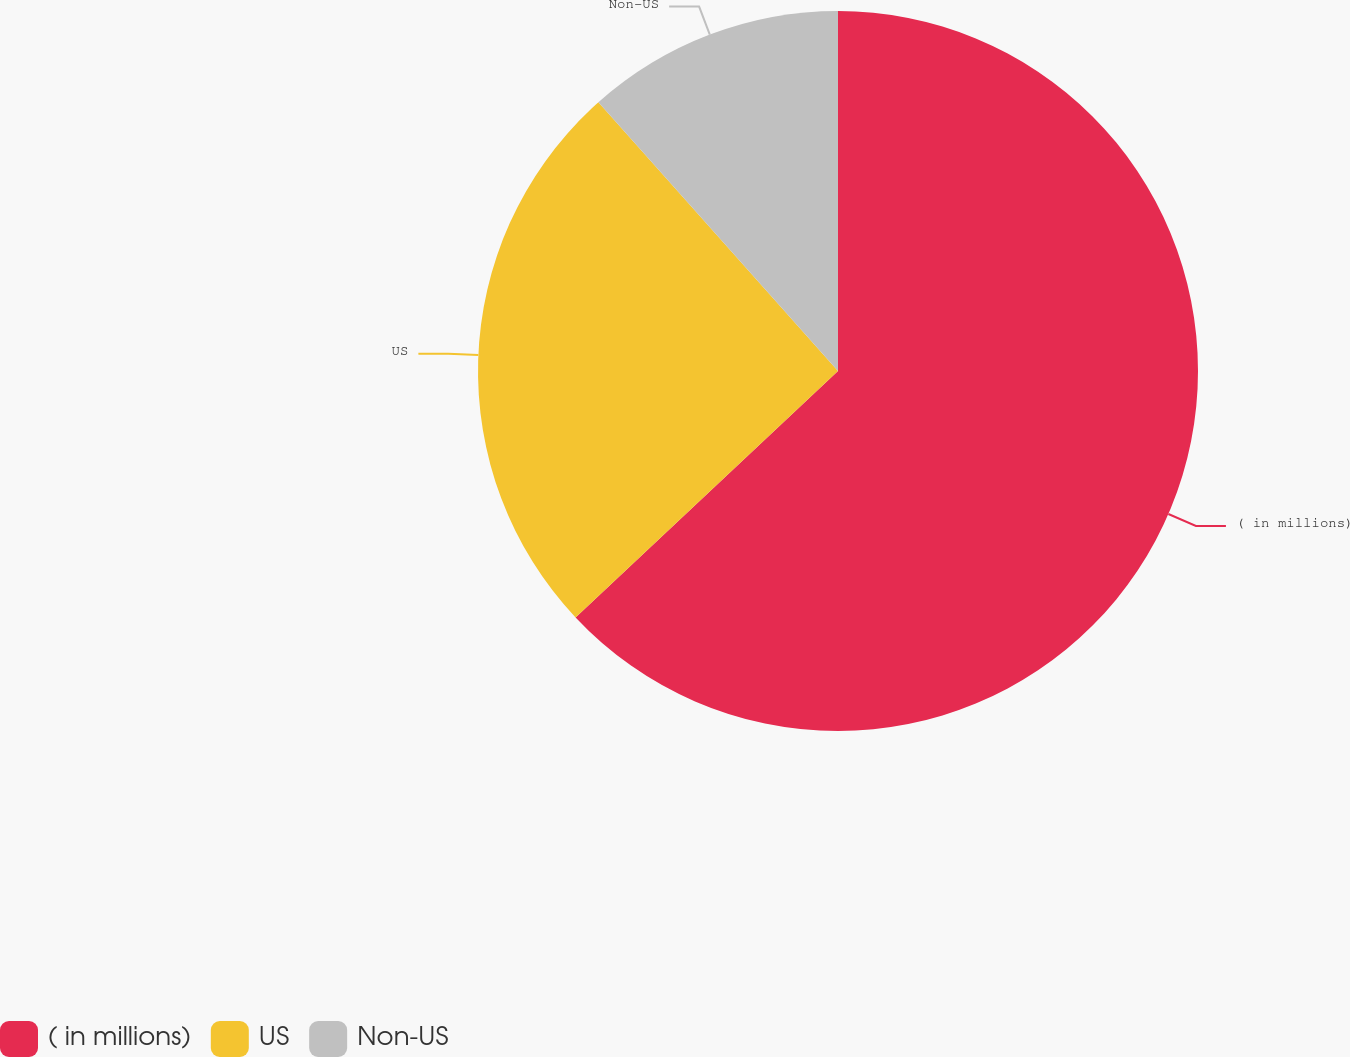Convert chart. <chart><loc_0><loc_0><loc_500><loc_500><pie_chart><fcel>( in millions)<fcel>US<fcel>Non-US<nl><fcel>63.0%<fcel>25.41%<fcel>11.59%<nl></chart> 